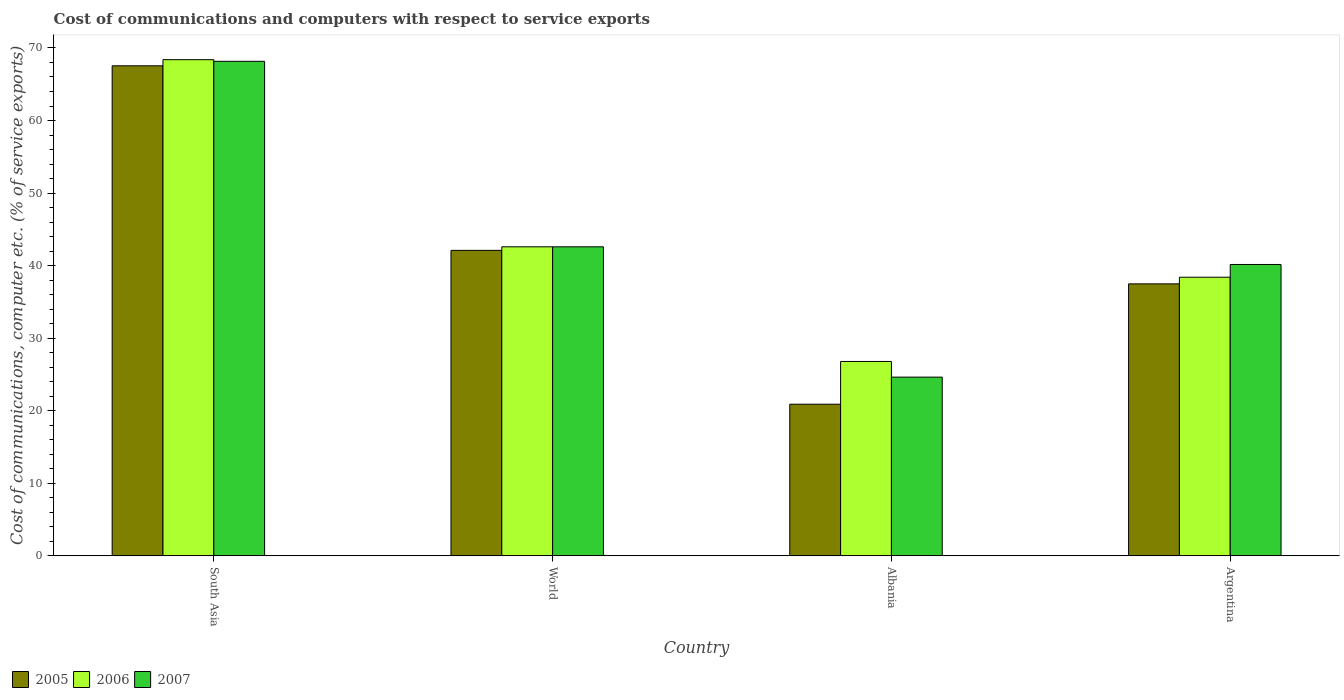How many different coloured bars are there?
Provide a short and direct response. 3. How many groups of bars are there?
Your response must be concise. 4. Are the number of bars per tick equal to the number of legend labels?
Your answer should be very brief. Yes. How many bars are there on the 4th tick from the right?
Provide a short and direct response. 3. What is the label of the 4th group of bars from the left?
Provide a succinct answer. Argentina. In how many cases, is the number of bars for a given country not equal to the number of legend labels?
Your response must be concise. 0. What is the cost of communications and computers in 2005 in Argentina?
Your answer should be compact. 37.49. Across all countries, what is the maximum cost of communications and computers in 2006?
Make the answer very short. 68.39. Across all countries, what is the minimum cost of communications and computers in 2005?
Offer a very short reply. 20.9. In which country was the cost of communications and computers in 2005 maximum?
Offer a terse response. South Asia. In which country was the cost of communications and computers in 2007 minimum?
Provide a short and direct response. Albania. What is the total cost of communications and computers in 2006 in the graph?
Provide a succinct answer. 176.17. What is the difference between the cost of communications and computers in 2006 in Albania and that in Argentina?
Your answer should be compact. -11.61. What is the difference between the cost of communications and computers in 2006 in Argentina and the cost of communications and computers in 2007 in South Asia?
Keep it short and to the point. -29.76. What is the average cost of communications and computers in 2007 per country?
Keep it short and to the point. 43.89. What is the difference between the cost of communications and computers of/in 2005 and cost of communications and computers of/in 2007 in Albania?
Offer a terse response. -3.73. What is the ratio of the cost of communications and computers in 2007 in Albania to that in Argentina?
Make the answer very short. 0.61. What is the difference between the highest and the second highest cost of communications and computers in 2005?
Your answer should be very brief. -25.44. What is the difference between the highest and the lowest cost of communications and computers in 2006?
Provide a short and direct response. 41.59. What does the 3rd bar from the right in South Asia represents?
Your answer should be compact. 2005. How many bars are there?
Give a very brief answer. 12. What is the difference between two consecutive major ticks on the Y-axis?
Offer a terse response. 10. Are the values on the major ticks of Y-axis written in scientific E-notation?
Ensure brevity in your answer.  No. Does the graph contain any zero values?
Offer a terse response. No. How many legend labels are there?
Your answer should be compact. 3. How are the legend labels stacked?
Your response must be concise. Horizontal. What is the title of the graph?
Your answer should be compact. Cost of communications and computers with respect to service exports. What is the label or title of the Y-axis?
Make the answer very short. Cost of communications, computer etc. (% of service exports). What is the Cost of communications, computer etc. (% of service exports) of 2005 in South Asia?
Your answer should be compact. 67.54. What is the Cost of communications, computer etc. (% of service exports) of 2006 in South Asia?
Offer a very short reply. 68.39. What is the Cost of communications, computer etc. (% of service exports) in 2007 in South Asia?
Your answer should be very brief. 68.16. What is the Cost of communications, computer etc. (% of service exports) of 2005 in World?
Give a very brief answer. 42.1. What is the Cost of communications, computer etc. (% of service exports) in 2006 in World?
Ensure brevity in your answer.  42.59. What is the Cost of communications, computer etc. (% of service exports) in 2007 in World?
Your answer should be very brief. 42.59. What is the Cost of communications, computer etc. (% of service exports) of 2005 in Albania?
Provide a short and direct response. 20.9. What is the Cost of communications, computer etc. (% of service exports) of 2006 in Albania?
Provide a succinct answer. 26.79. What is the Cost of communications, computer etc. (% of service exports) in 2007 in Albania?
Offer a terse response. 24.63. What is the Cost of communications, computer etc. (% of service exports) in 2005 in Argentina?
Keep it short and to the point. 37.49. What is the Cost of communications, computer etc. (% of service exports) of 2006 in Argentina?
Offer a terse response. 38.4. What is the Cost of communications, computer etc. (% of service exports) in 2007 in Argentina?
Your answer should be compact. 40.16. Across all countries, what is the maximum Cost of communications, computer etc. (% of service exports) in 2005?
Provide a short and direct response. 67.54. Across all countries, what is the maximum Cost of communications, computer etc. (% of service exports) of 2006?
Your answer should be compact. 68.39. Across all countries, what is the maximum Cost of communications, computer etc. (% of service exports) of 2007?
Your response must be concise. 68.16. Across all countries, what is the minimum Cost of communications, computer etc. (% of service exports) in 2005?
Offer a terse response. 20.9. Across all countries, what is the minimum Cost of communications, computer etc. (% of service exports) of 2006?
Your response must be concise. 26.79. Across all countries, what is the minimum Cost of communications, computer etc. (% of service exports) in 2007?
Provide a succinct answer. 24.63. What is the total Cost of communications, computer etc. (% of service exports) in 2005 in the graph?
Give a very brief answer. 168.03. What is the total Cost of communications, computer etc. (% of service exports) of 2006 in the graph?
Provide a succinct answer. 176.17. What is the total Cost of communications, computer etc. (% of service exports) in 2007 in the graph?
Give a very brief answer. 175.54. What is the difference between the Cost of communications, computer etc. (% of service exports) in 2005 in South Asia and that in World?
Ensure brevity in your answer.  25.44. What is the difference between the Cost of communications, computer etc. (% of service exports) in 2006 in South Asia and that in World?
Your answer should be very brief. 25.79. What is the difference between the Cost of communications, computer etc. (% of service exports) of 2007 in South Asia and that in World?
Offer a very short reply. 25.57. What is the difference between the Cost of communications, computer etc. (% of service exports) in 2005 in South Asia and that in Albania?
Offer a terse response. 46.64. What is the difference between the Cost of communications, computer etc. (% of service exports) in 2006 in South Asia and that in Albania?
Ensure brevity in your answer.  41.59. What is the difference between the Cost of communications, computer etc. (% of service exports) in 2007 in South Asia and that in Albania?
Offer a very short reply. 43.53. What is the difference between the Cost of communications, computer etc. (% of service exports) of 2005 in South Asia and that in Argentina?
Make the answer very short. 30.06. What is the difference between the Cost of communications, computer etc. (% of service exports) in 2006 in South Asia and that in Argentina?
Offer a terse response. 29.98. What is the difference between the Cost of communications, computer etc. (% of service exports) in 2007 in South Asia and that in Argentina?
Offer a very short reply. 28. What is the difference between the Cost of communications, computer etc. (% of service exports) in 2005 in World and that in Albania?
Offer a terse response. 21.2. What is the difference between the Cost of communications, computer etc. (% of service exports) in 2006 in World and that in Albania?
Ensure brevity in your answer.  15.8. What is the difference between the Cost of communications, computer etc. (% of service exports) of 2007 in World and that in Albania?
Make the answer very short. 17.96. What is the difference between the Cost of communications, computer etc. (% of service exports) in 2005 in World and that in Argentina?
Your answer should be compact. 4.62. What is the difference between the Cost of communications, computer etc. (% of service exports) in 2006 in World and that in Argentina?
Provide a succinct answer. 4.19. What is the difference between the Cost of communications, computer etc. (% of service exports) in 2007 in World and that in Argentina?
Your answer should be very brief. 2.43. What is the difference between the Cost of communications, computer etc. (% of service exports) of 2005 in Albania and that in Argentina?
Offer a very short reply. -16.59. What is the difference between the Cost of communications, computer etc. (% of service exports) in 2006 in Albania and that in Argentina?
Make the answer very short. -11.61. What is the difference between the Cost of communications, computer etc. (% of service exports) in 2007 in Albania and that in Argentina?
Ensure brevity in your answer.  -15.53. What is the difference between the Cost of communications, computer etc. (% of service exports) of 2005 in South Asia and the Cost of communications, computer etc. (% of service exports) of 2006 in World?
Make the answer very short. 24.95. What is the difference between the Cost of communications, computer etc. (% of service exports) in 2005 in South Asia and the Cost of communications, computer etc. (% of service exports) in 2007 in World?
Provide a succinct answer. 24.95. What is the difference between the Cost of communications, computer etc. (% of service exports) in 2006 in South Asia and the Cost of communications, computer etc. (% of service exports) in 2007 in World?
Ensure brevity in your answer.  25.79. What is the difference between the Cost of communications, computer etc. (% of service exports) in 2005 in South Asia and the Cost of communications, computer etc. (% of service exports) in 2006 in Albania?
Your response must be concise. 40.75. What is the difference between the Cost of communications, computer etc. (% of service exports) in 2005 in South Asia and the Cost of communications, computer etc. (% of service exports) in 2007 in Albania?
Keep it short and to the point. 42.91. What is the difference between the Cost of communications, computer etc. (% of service exports) in 2006 in South Asia and the Cost of communications, computer etc. (% of service exports) in 2007 in Albania?
Offer a very short reply. 43.75. What is the difference between the Cost of communications, computer etc. (% of service exports) in 2005 in South Asia and the Cost of communications, computer etc. (% of service exports) in 2006 in Argentina?
Give a very brief answer. 29.14. What is the difference between the Cost of communications, computer etc. (% of service exports) of 2005 in South Asia and the Cost of communications, computer etc. (% of service exports) of 2007 in Argentina?
Provide a succinct answer. 27.38. What is the difference between the Cost of communications, computer etc. (% of service exports) of 2006 in South Asia and the Cost of communications, computer etc. (% of service exports) of 2007 in Argentina?
Your answer should be compact. 28.23. What is the difference between the Cost of communications, computer etc. (% of service exports) in 2005 in World and the Cost of communications, computer etc. (% of service exports) in 2006 in Albania?
Ensure brevity in your answer.  15.31. What is the difference between the Cost of communications, computer etc. (% of service exports) of 2005 in World and the Cost of communications, computer etc. (% of service exports) of 2007 in Albania?
Provide a succinct answer. 17.47. What is the difference between the Cost of communications, computer etc. (% of service exports) in 2006 in World and the Cost of communications, computer etc. (% of service exports) in 2007 in Albania?
Your answer should be very brief. 17.96. What is the difference between the Cost of communications, computer etc. (% of service exports) of 2005 in World and the Cost of communications, computer etc. (% of service exports) of 2006 in Argentina?
Your response must be concise. 3.7. What is the difference between the Cost of communications, computer etc. (% of service exports) in 2005 in World and the Cost of communications, computer etc. (% of service exports) in 2007 in Argentina?
Give a very brief answer. 1.95. What is the difference between the Cost of communications, computer etc. (% of service exports) in 2006 in World and the Cost of communications, computer etc. (% of service exports) in 2007 in Argentina?
Offer a terse response. 2.44. What is the difference between the Cost of communications, computer etc. (% of service exports) of 2005 in Albania and the Cost of communications, computer etc. (% of service exports) of 2006 in Argentina?
Your response must be concise. -17.5. What is the difference between the Cost of communications, computer etc. (% of service exports) of 2005 in Albania and the Cost of communications, computer etc. (% of service exports) of 2007 in Argentina?
Ensure brevity in your answer.  -19.26. What is the difference between the Cost of communications, computer etc. (% of service exports) in 2006 in Albania and the Cost of communications, computer etc. (% of service exports) in 2007 in Argentina?
Your answer should be very brief. -13.37. What is the average Cost of communications, computer etc. (% of service exports) in 2005 per country?
Keep it short and to the point. 42.01. What is the average Cost of communications, computer etc. (% of service exports) in 2006 per country?
Make the answer very short. 44.04. What is the average Cost of communications, computer etc. (% of service exports) in 2007 per country?
Give a very brief answer. 43.89. What is the difference between the Cost of communications, computer etc. (% of service exports) of 2005 and Cost of communications, computer etc. (% of service exports) of 2006 in South Asia?
Provide a succinct answer. -0.84. What is the difference between the Cost of communications, computer etc. (% of service exports) in 2005 and Cost of communications, computer etc. (% of service exports) in 2007 in South Asia?
Keep it short and to the point. -0.62. What is the difference between the Cost of communications, computer etc. (% of service exports) of 2006 and Cost of communications, computer etc. (% of service exports) of 2007 in South Asia?
Your answer should be very brief. 0.22. What is the difference between the Cost of communications, computer etc. (% of service exports) of 2005 and Cost of communications, computer etc. (% of service exports) of 2006 in World?
Offer a terse response. -0.49. What is the difference between the Cost of communications, computer etc. (% of service exports) in 2005 and Cost of communications, computer etc. (% of service exports) in 2007 in World?
Make the answer very short. -0.49. What is the difference between the Cost of communications, computer etc. (% of service exports) in 2006 and Cost of communications, computer etc. (% of service exports) in 2007 in World?
Provide a short and direct response. 0. What is the difference between the Cost of communications, computer etc. (% of service exports) of 2005 and Cost of communications, computer etc. (% of service exports) of 2006 in Albania?
Make the answer very short. -5.89. What is the difference between the Cost of communications, computer etc. (% of service exports) in 2005 and Cost of communications, computer etc. (% of service exports) in 2007 in Albania?
Your answer should be compact. -3.73. What is the difference between the Cost of communications, computer etc. (% of service exports) of 2006 and Cost of communications, computer etc. (% of service exports) of 2007 in Albania?
Give a very brief answer. 2.16. What is the difference between the Cost of communications, computer etc. (% of service exports) in 2005 and Cost of communications, computer etc. (% of service exports) in 2006 in Argentina?
Keep it short and to the point. -0.92. What is the difference between the Cost of communications, computer etc. (% of service exports) in 2005 and Cost of communications, computer etc. (% of service exports) in 2007 in Argentina?
Your answer should be compact. -2.67. What is the difference between the Cost of communications, computer etc. (% of service exports) of 2006 and Cost of communications, computer etc. (% of service exports) of 2007 in Argentina?
Keep it short and to the point. -1.76. What is the ratio of the Cost of communications, computer etc. (% of service exports) in 2005 in South Asia to that in World?
Offer a very short reply. 1.6. What is the ratio of the Cost of communications, computer etc. (% of service exports) of 2006 in South Asia to that in World?
Ensure brevity in your answer.  1.61. What is the ratio of the Cost of communications, computer etc. (% of service exports) of 2007 in South Asia to that in World?
Keep it short and to the point. 1.6. What is the ratio of the Cost of communications, computer etc. (% of service exports) in 2005 in South Asia to that in Albania?
Ensure brevity in your answer.  3.23. What is the ratio of the Cost of communications, computer etc. (% of service exports) of 2006 in South Asia to that in Albania?
Your response must be concise. 2.55. What is the ratio of the Cost of communications, computer etc. (% of service exports) in 2007 in South Asia to that in Albania?
Your response must be concise. 2.77. What is the ratio of the Cost of communications, computer etc. (% of service exports) in 2005 in South Asia to that in Argentina?
Keep it short and to the point. 1.8. What is the ratio of the Cost of communications, computer etc. (% of service exports) of 2006 in South Asia to that in Argentina?
Give a very brief answer. 1.78. What is the ratio of the Cost of communications, computer etc. (% of service exports) of 2007 in South Asia to that in Argentina?
Provide a succinct answer. 1.7. What is the ratio of the Cost of communications, computer etc. (% of service exports) in 2005 in World to that in Albania?
Provide a short and direct response. 2.01. What is the ratio of the Cost of communications, computer etc. (% of service exports) in 2006 in World to that in Albania?
Make the answer very short. 1.59. What is the ratio of the Cost of communications, computer etc. (% of service exports) of 2007 in World to that in Albania?
Provide a succinct answer. 1.73. What is the ratio of the Cost of communications, computer etc. (% of service exports) of 2005 in World to that in Argentina?
Offer a terse response. 1.12. What is the ratio of the Cost of communications, computer etc. (% of service exports) of 2006 in World to that in Argentina?
Ensure brevity in your answer.  1.11. What is the ratio of the Cost of communications, computer etc. (% of service exports) in 2007 in World to that in Argentina?
Your response must be concise. 1.06. What is the ratio of the Cost of communications, computer etc. (% of service exports) in 2005 in Albania to that in Argentina?
Provide a succinct answer. 0.56. What is the ratio of the Cost of communications, computer etc. (% of service exports) in 2006 in Albania to that in Argentina?
Keep it short and to the point. 0.7. What is the ratio of the Cost of communications, computer etc. (% of service exports) in 2007 in Albania to that in Argentina?
Provide a short and direct response. 0.61. What is the difference between the highest and the second highest Cost of communications, computer etc. (% of service exports) of 2005?
Ensure brevity in your answer.  25.44. What is the difference between the highest and the second highest Cost of communications, computer etc. (% of service exports) of 2006?
Your answer should be very brief. 25.79. What is the difference between the highest and the second highest Cost of communications, computer etc. (% of service exports) in 2007?
Offer a very short reply. 25.57. What is the difference between the highest and the lowest Cost of communications, computer etc. (% of service exports) in 2005?
Offer a terse response. 46.64. What is the difference between the highest and the lowest Cost of communications, computer etc. (% of service exports) in 2006?
Make the answer very short. 41.59. What is the difference between the highest and the lowest Cost of communications, computer etc. (% of service exports) in 2007?
Your answer should be compact. 43.53. 